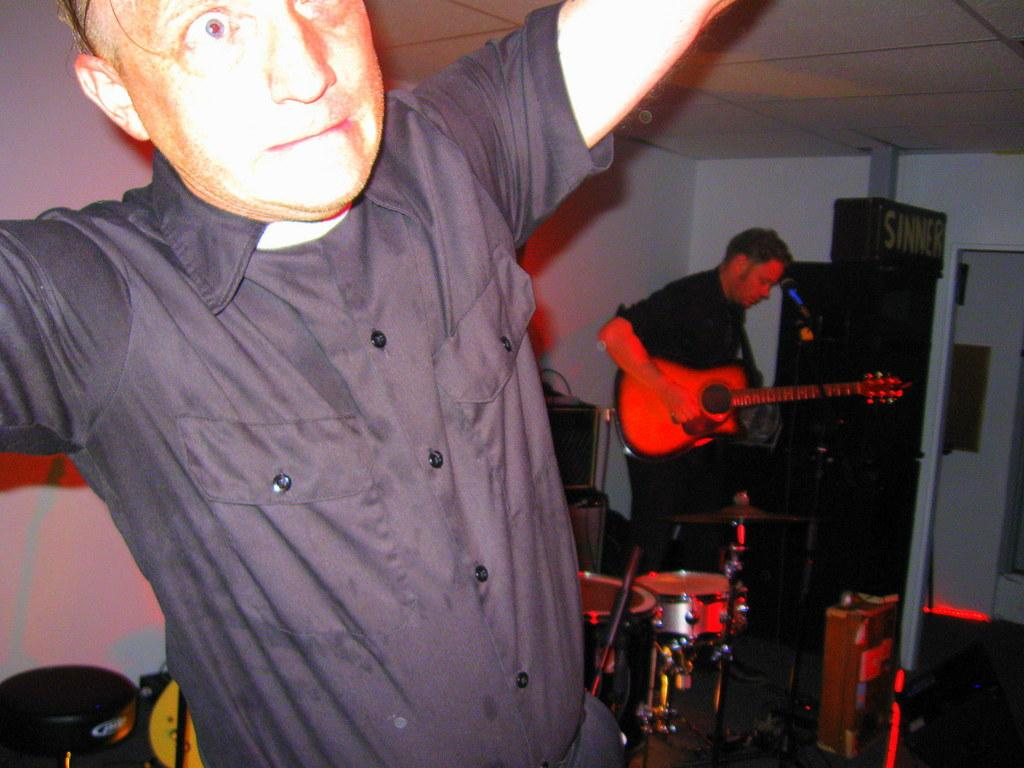What is the main subject of the image? There are two men in the image, with one standing in the center and another on the right side. What is the man on the right side holding? The man on the right side is holding a guitar. What object is in front of the man on the right side? There is a microphone in front of the man on the right side. Can you see any stems or tins in the image? There are no stems or tins present in the image. Is there a squirrel visible in the image? No, there is no squirrel visible in the image. 